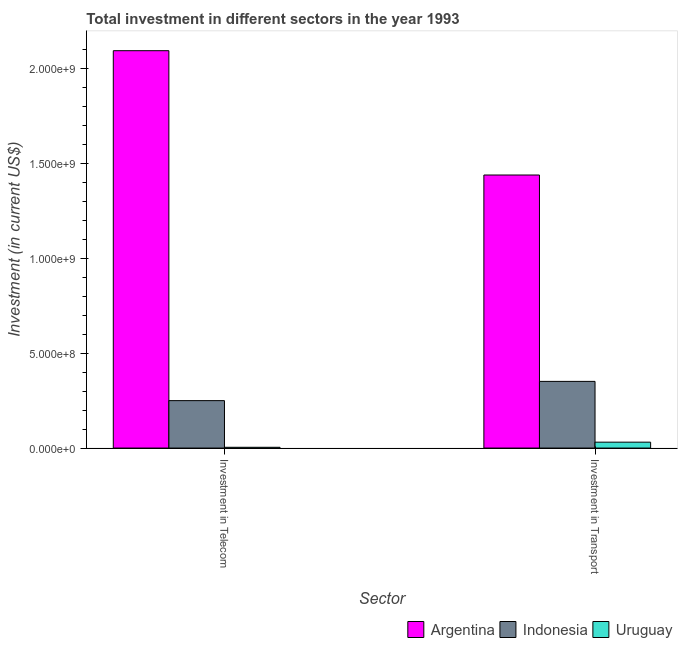Are the number of bars per tick equal to the number of legend labels?
Offer a terse response. Yes. How many bars are there on the 2nd tick from the right?
Give a very brief answer. 3. What is the label of the 1st group of bars from the left?
Make the answer very short. Investment in Telecom. What is the investment in telecom in Uruguay?
Provide a succinct answer. 4.00e+06. Across all countries, what is the maximum investment in telecom?
Make the answer very short. 2.10e+09. Across all countries, what is the minimum investment in transport?
Offer a very short reply. 3.10e+07. In which country was the investment in transport maximum?
Offer a very short reply. Argentina. In which country was the investment in transport minimum?
Offer a terse response. Uruguay. What is the total investment in telecom in the graph?
Make the answer very short. 2.35e+09. What is the difference between the investment in transport in Argentina and that in Indonesia?
Your response must be concise. 1.09e+09. What is the difference between the investment in telecom in Indonesia and the investment in transport in Uruguay?
Provide a succinct answer. 2.19e+08. What is the average investment in transport per country?
Your response must be concise. 6.07e+08. What is the difference between the investment in telecom and investment in transport in Argentina?
Give a very brief answer. 6.55e+08. In how many countries, is the investment in transport greater than 1800000000 US$?
Offer a very short reply. 0. What is the ratio of the investment in transport in Argentina to that in Uruguay?
Offer a terse response. 46.44. Is the investment in telecom in Indonesia less than that in Argentina?
Your answer should be compact. Yes. What does the 3rd bar from the left in Investment in Transport represents?
Give a very brief answer. Uruguay. What does the 3rd bar from the right in Investment in Telecom represents?
Your answer should be compact. Argentina. How many bars are there?
Your response must be concise. 6. What is the difference between two consecutive major ticks on the Y-axis?
Provide a short and direct response. 5.00e+08. Does the graph contain any zero values?
Your answer should be very brief. No. Does the graph contain grids?
Ensure brevity in your answer.  No. Where does the legend appear in the graph?
Provide a short and direct response. Bottom right. How many legend labels are there?
Give a very brief answer. 3. How are the legend labels stacked?
Offer a terse response. Horizontal. What is the title of the graph?
Your answer should be compact. Total investment in different sectors in the year 1993. Does "Qatar" appear as one of the legend labels in the graph?
Your answer should be compact. No. What is the label or title of the X-axis?
Your answer should be compact. Sector. What is the label or title of the Y-axis?
Keep it short and to the point. Investment (in current US$). What is the Investment (in current US$) of Argentina in Investment in Telecom?
Ensure brevity in your answer.  2.10e+09. What is the Investment (in current US$) of Indonesia in Investment in Telecom?
Offer a terse response. 2.50e+08. What is the Investment (in current US$) of Uruguay in Investment in Telecom?
Give a very brief answer. 4.00e+06. What is the Investment (in current US$) of Argentina in Investment in Transport?
Make the answer very short. 1.44e+09. What is the Investment (in current US$) of Indonesia in Investment in Transport?
Your answer should be very brief. 3.52e+08. What is the Investment (in current US$) of Uruguay in Investment in Transport?
Provide a short and direct response. 3.10e+07. Across all Sector, what is the maximum Investment (in current US$) of Argentina?
Offer a very short reply. 2.10e+09. Across all Sector, what is the maximum Investment (in current US$) of Indonesia?
Offer a very short reply. 3.52e+08. Across all Sector, what is the maximum Investment (in current US$) of Uruguay?
Provide a short and direct response. 3.10e+07. Across all Sector, what is the minimum Investment (in current US$) in Argentina?
Your answer should be very brief. 1.44e+09. Across all Sector, what is the minimum Investment (in current US$) of Indonesia?
Give a very brief answer. 2.50e+08. What is the total Investment (in current US$) of Argentina in the graph?
Make the answer very short. 3.53e+09. What is the total Investment (in current US$) of Indonesia in the graph?
Make the answer very short. 6.02e+08. What is the total Investment (in current US$) in Uruguay in the graph?
Offer a very short reply. 3.50e+07. What is the difference between the Investment (in current US$) of Argentina in Investment in Telecom and that in Investment in Transport?
Offer a very short reply. 6.55e+08. What is the difference between the Investment (in current US$) of Indonesia in Investment in Telecom and that in Investment in Transport?
Offer a terse response. -1.02e+08. What is the difference between the Investment (in current US$) in Uruguay in Investment in Telecom and that in Investment in Transport?
Provide a short and direct response. -2.70e+07. What is the difference between the Investment (in current US$) in Argentina in Investment in Telecom and the Investment (in current US$) in Indonesia in Investment in Transport?
Provide a succinct answer. 1.74e+09. What is the difference between the Investment (in current US$) in Argentina in Investment in Telecom and the Investment (in current US$) in Uruguay in Investment in Transport?
Keep it short and to the point. 2.06e+09. What is the difference between the Investment (in current US$) of Indonesia in Investment in Telecom and the Investment (in current US$) of Uruguay in Investment in Transport?
Ensure brevity in your answer.  2.19e+08. What is the average Investment (in current US$) of Argentina per Sector?
Provide a succinct answer. 1.77e+09. What is the average Investment (in current US$) in Indonesia per Sector?
Provide a succinct answer. 3.01e+08. What is the average Investment (in current US$) in Uruguay per Sector?
Offer a terse response. 1.75e+07. What is the difference between the Investment (in current US$) of Argentina and Investment (in current US$) of Indonesia in Investment in Telecom?
Offer a very short reply. 1.84e+09. What is the difference between the Investment (in current US$) in Argentina and Investment (in current US$) in Uruguay in Investment in Telecom?
Provide a short and direct response. 2.09e+09. What is the difference between the Investment (in current US$) in Indonesia and Investment (in current US$) in Uruguay in Investment in Telecom?
Keep it short and to the point. 2.46e+08. What is the difference between the Investment (in current US$) in Argentina and Investment (in current US$) in Indonesia in Investment in Transport?
Provide a short and direct response. 1.09e+09. What is the difference between the Investment (in current US$) of Argentina and Investment (in current US$) of Uruguay in Investment in Transport?
Make the answer very short. 1.41e+09. What is the difference between the Investment (in current US$) in Indonesia and Investment (in current US$) in Uruguay in Investment in Transport?
Your answer should be very brief. 3.20e+08. What is the ratio of the Investment (in current US$) in Argentina in Investment in Telecom to that in Investment in Transport?
Provide a succinct answer. 1.46. What is the ratio of the Investment (in current US$) in Indonesia in Investment in Telecom to that in Investment in Transport?
Give a very brief answer. 0.71. What is the ratio of the Investment (in current US$) of Uruguay in Investment in Telecom to that in Investment in Transport?
Your answer should be very brief. 0.13. What is the difference between the highest and the second highest Investment (in current US$) of Argentina?
Provide a short and direct response. 6.55e+08. What is the difference between the highest and the second highest Investment (in current US$) of Indonesia?
Keep it short and to the point. 1.02e+08. What is the difference between the highest and the second highest Investment (in current US$) in Uruguay?
Make the answer very short. 2.70e+07. What is the difference between the highest and the lowest Investment (in current US$) in Argentina?
Provide a succinct answer. 6.55e+08. What is the difference between the highest and the lowest Investment (in current US$) in Indonesia?
Give a very brief answer. 1.02e+08. What is the difference between the highest and the lowest Investment (in current US$) in Uruguay?
Make the answer very short. 2.70e+07. 